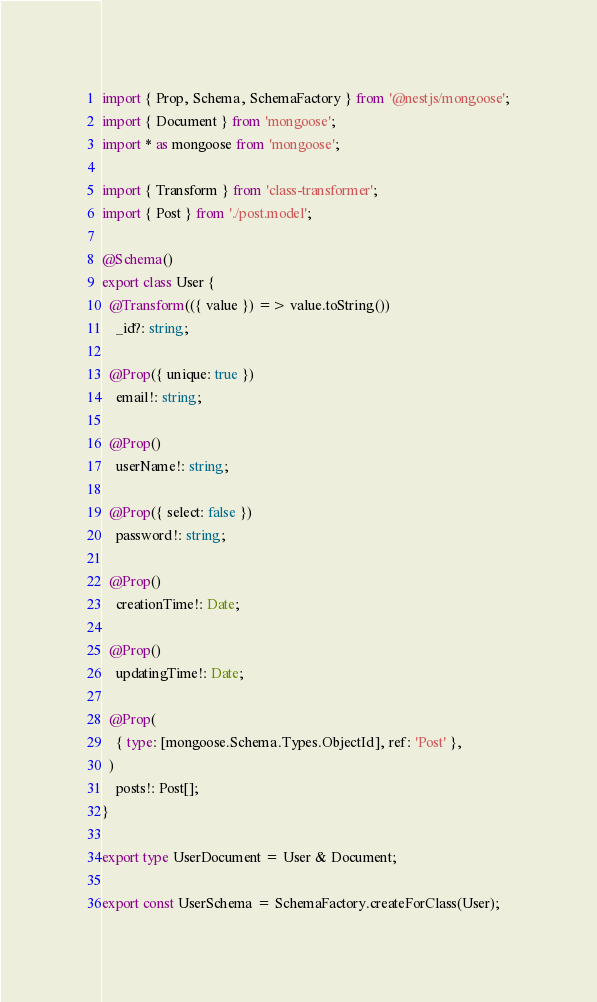Convert code to text. <code><loc_0><loc_0><loc_500><loc_500><_TypeScript_>import { Prop, Schema, SchemaFactory } from '@nestjs/mongoose';
import { Document } from 'mongoose';
import * as mongoose from 'mongoose';

import { Transform } from 'class-transformer';
import { Post } from './post.model';

@Schema()
export class User {
  @Transform(({ value }) => value.toString())
    _id?: string;

  @Prop({ unique: true })
    email!: string;

  @Prop()
    userName!: string;

  @Prop({ select: false })
    password!: string;

  @Prop()
    creationTime!: Date;

  @Prop()
    updatingTime!: Date;

  @Prop(
    { type: [mongoose.Schema.Types.ObjectId], ref: 'Post' },
  )
    posts!: Post[];
}

export type UserDocument = User & Document;

export const UserSchema = SchemaFactory.createForClass(User);
</code> 